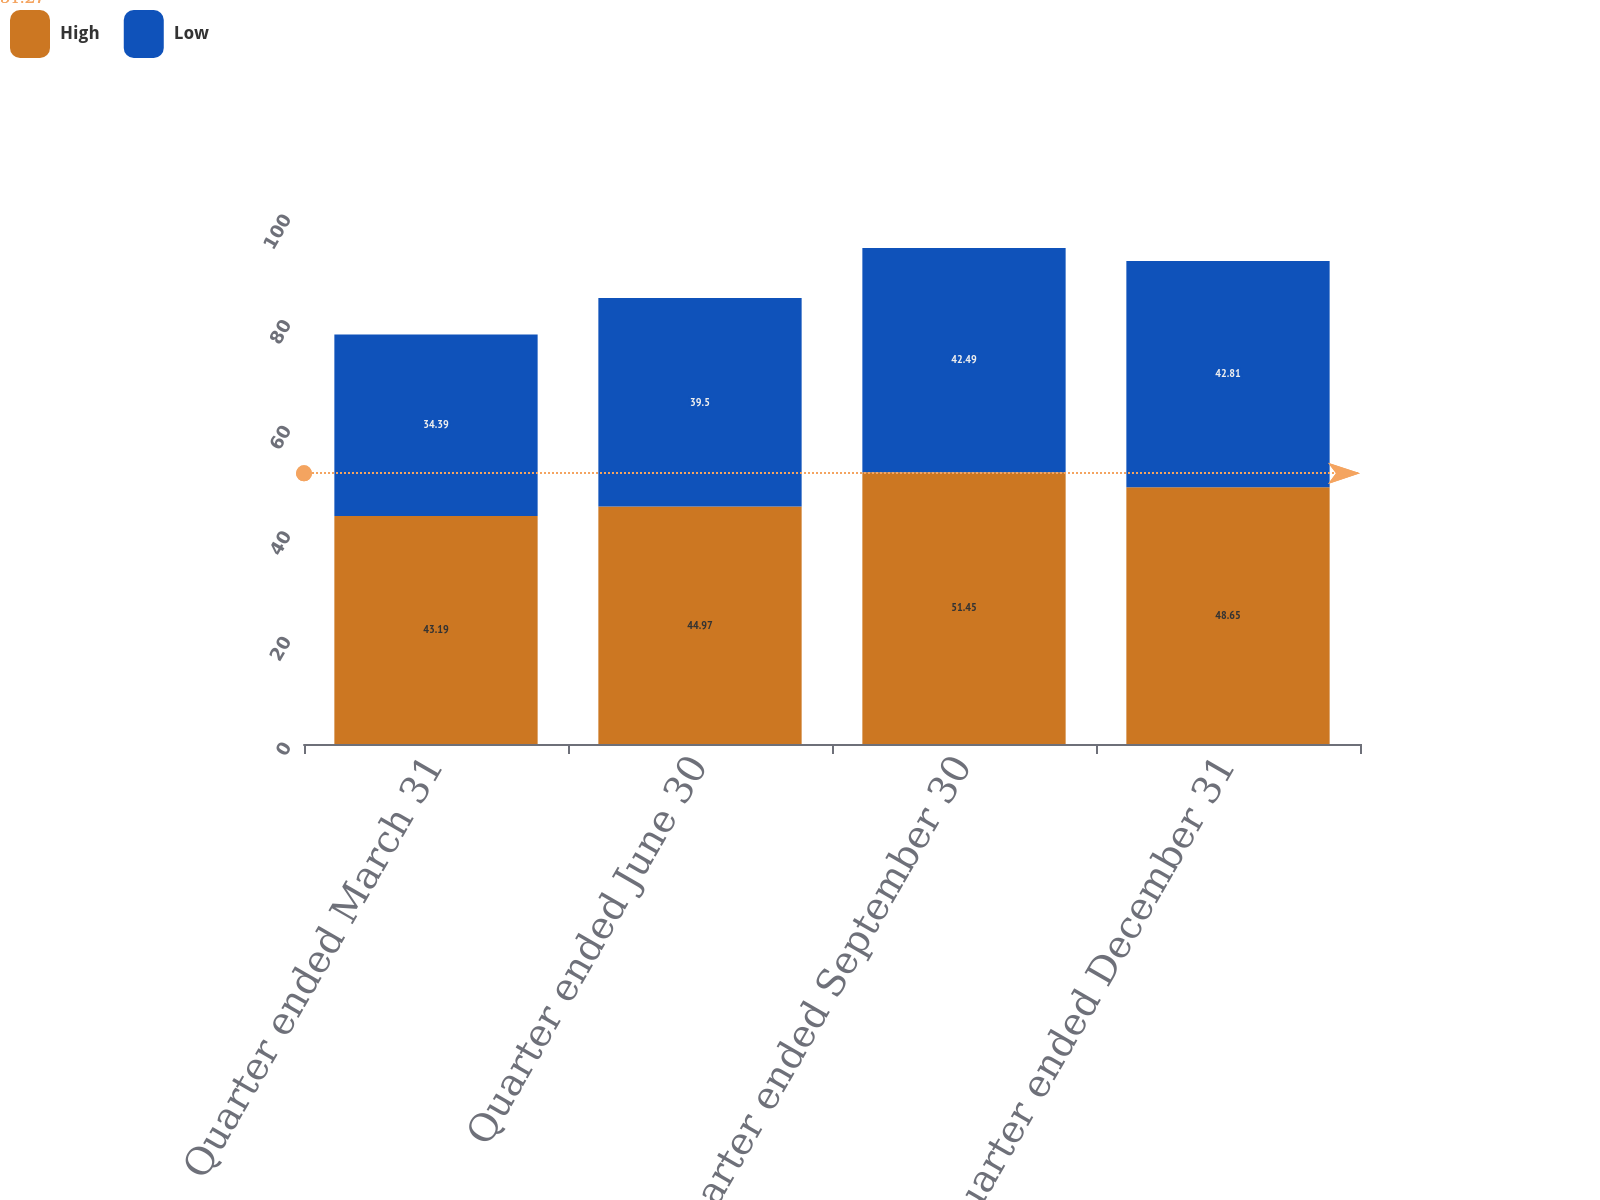<chart> <loc_0><loc_0><loc_500><loc_500><stacked_bar_chart><ecel><fcel>Quarter ended March 31<fcel>Quarter ended June 30<fcel>Quarter ended September 30<fcel>Quarter ended December 31<nl><fcel>High<fcel>43.19<fcel>44.97<fcel>51.45<fcel>48.65<nl><fcel>Low<fcel>34.39<fcel>39.5<fcel>42.49<fcel>42.81<nl></chart> 